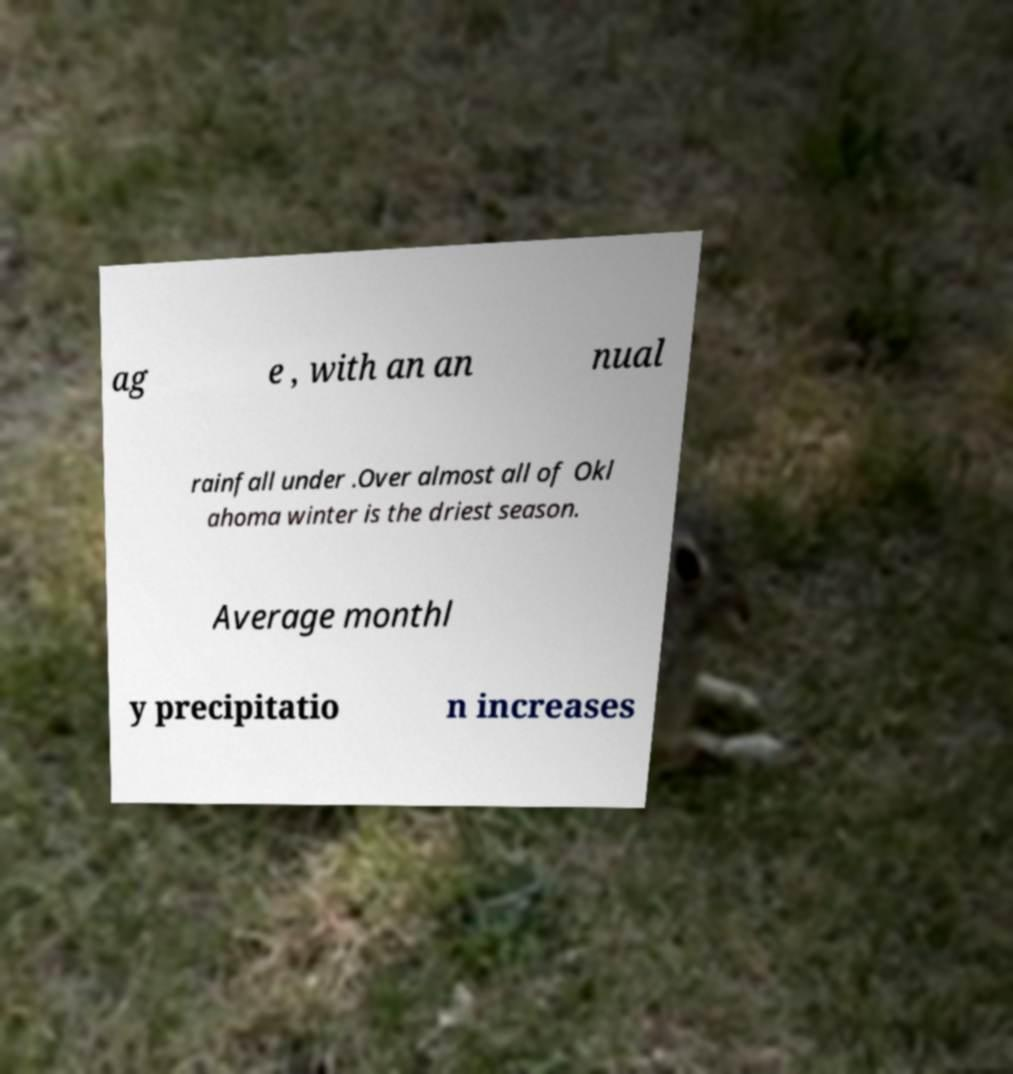Please read and relay the text visible in this image. What does it say? ag e , with an an nual rainfall under .Over almost all of Okl ahoma winter is the driest season. Average monthl y precipitatio n increases 